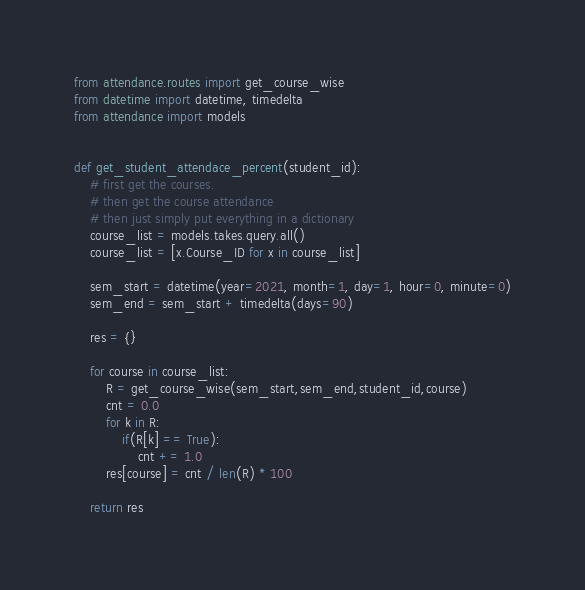<code> <loc_0><loc_0><loc_500><loc_500><_Python_>from attendance.routes import get_course_wise
from datetime import datetime, timedelta
from attendance import models


def get_student_attendace_percent(student_id):
    # first get the courses.
    # then get the course attendance
    # then just simply put everything in a dictionary
    course_list = models.takes.query.all()
    course_list = [x.Course_ID for x in course_list]

    sem_start = datetime(year=2021, month=1, day=1, hour=0, minute=0)
    sem_end = sem_start + timedelta(days=90)
    
    res = {}

    for course in course_list:
        R = get_course_wise(sem_start,sem_end,student_id,course)
        cnt = 0.0
        for k in R:
            if(R[k] == True):
                cnt += 1.0
        res[course] = cnt / len(R) * 100

    return res
</code> 